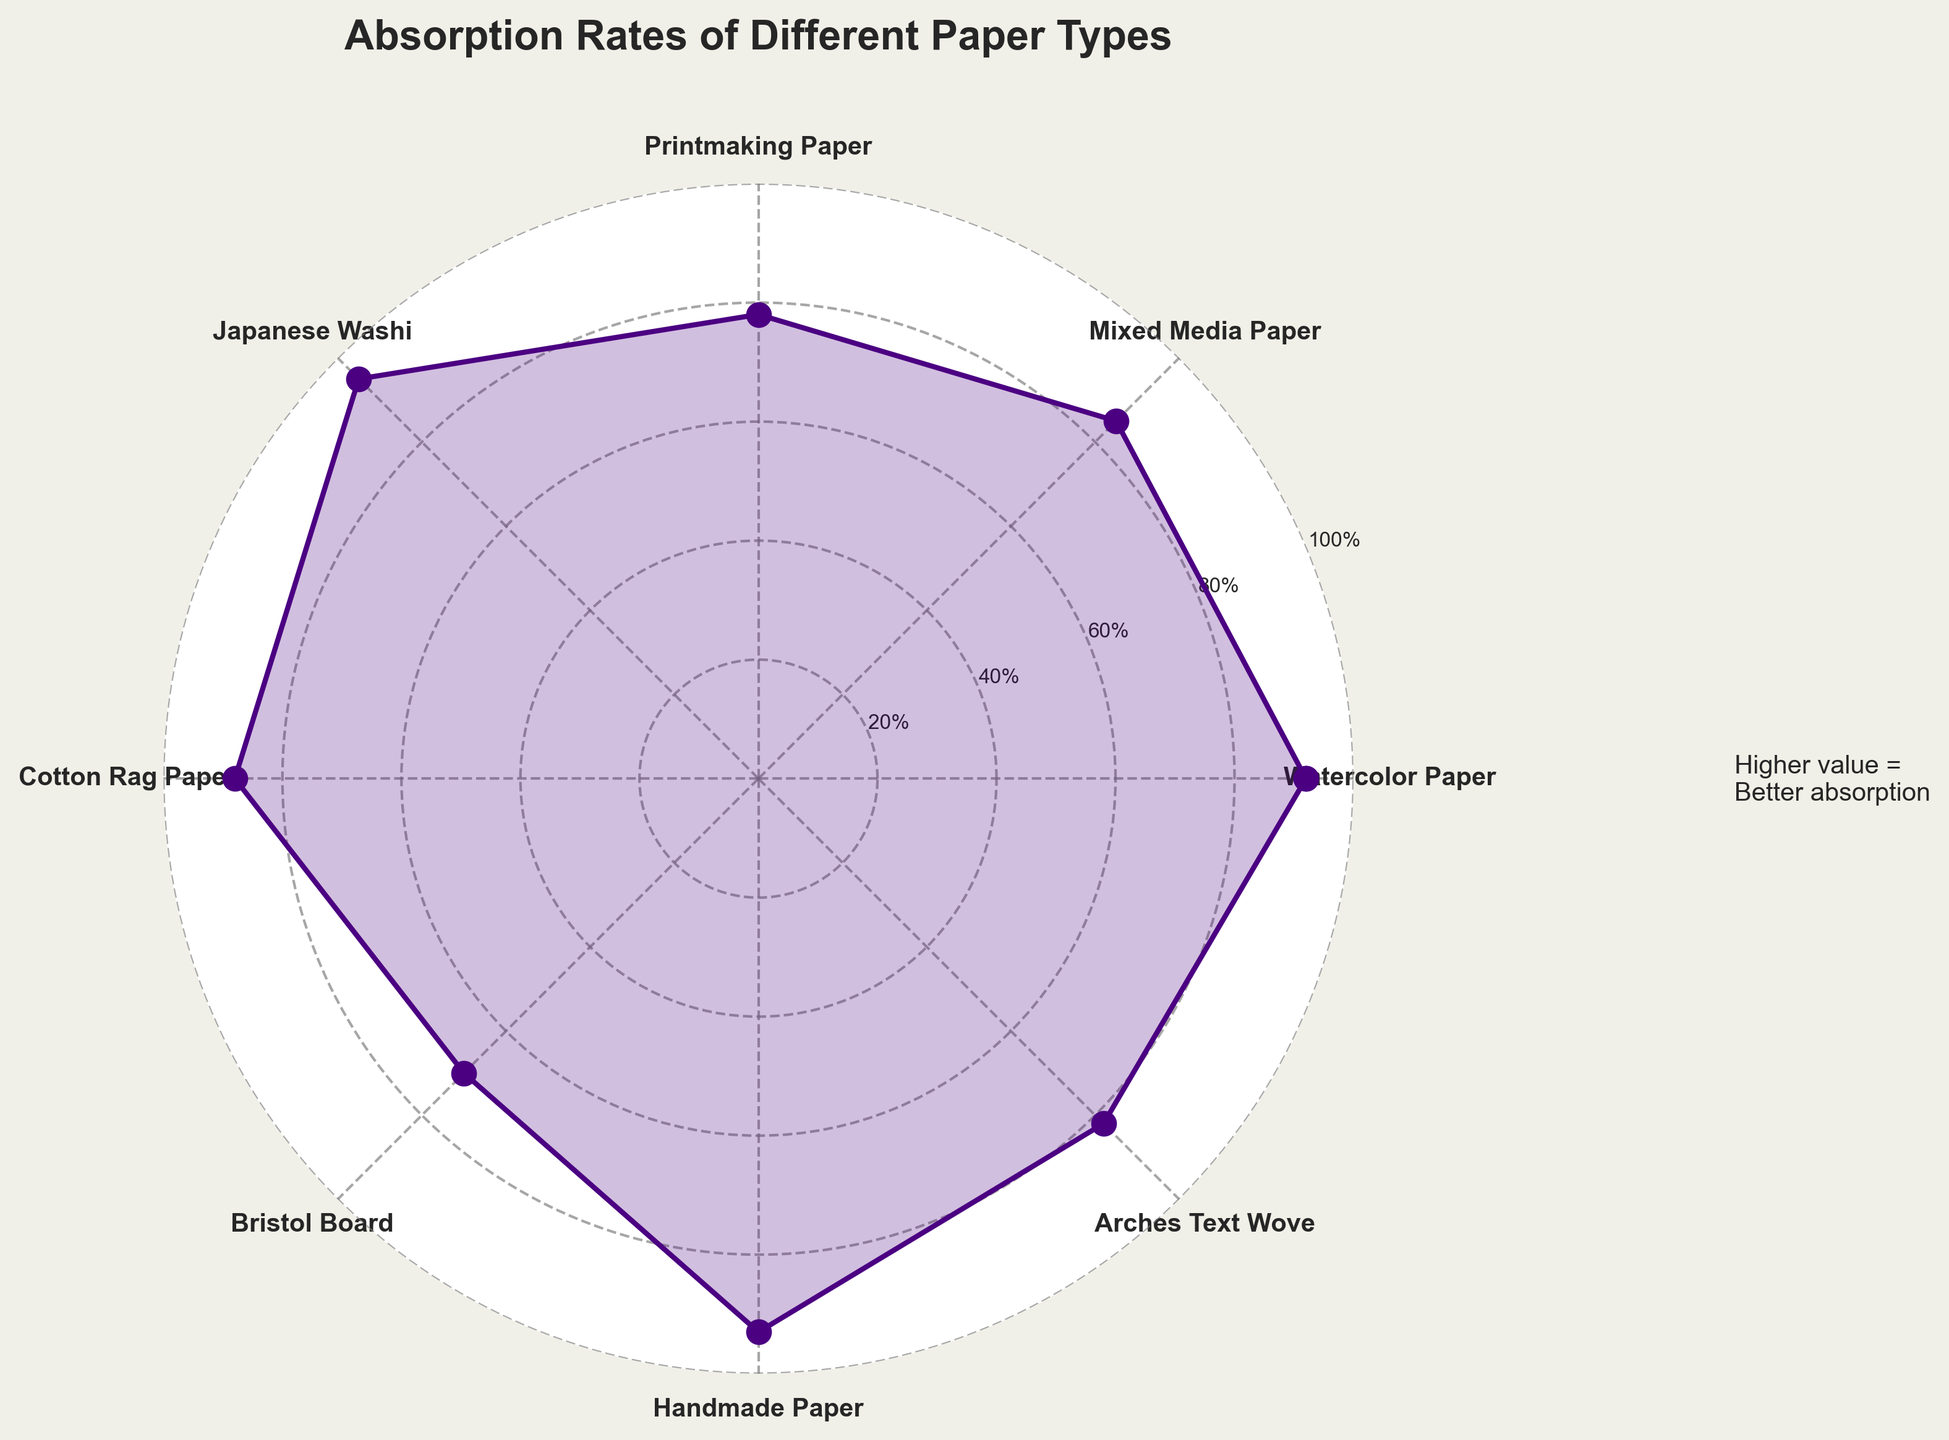What is the title of the gauge chart? The title is located at the top of the chart and is displayed in bold.
Answer: Absorption Rates of Different Paper Types What color is used for plotting the data points and the filled polygon? The color is visually consistent across the data points and the filled area of the polygon.
Answer: Indigo How many different paper types are represented in the gauge chart? Count the number of unique labels distributed around the polar axis of the chart.
Answer: Eight Which paper type has the highest absorption rate? Identify the paper type at the highest value on the radial scale.
Answer: Japanese Washi Which paper type has the lowest absorption rate? Identify the paper type at the lowest value on the radial scale.
Answer: Bristol Board What is the difference in absorption rates between Watercolor Paper and Bristol Board? Subtract the absorption rate of Bristol Board from that of Watercolor Paper.
Answer: 22 Which paper types have absorption rates greater than 90%? Identify paper types with values exceeding 90% on the radial scale.
Answer: Watercolor Paper, Japanese Washi, Handmade Paper What is the average absorption rate of all the paper types? Add all the absorption rates and divide by the number of paper types. The calculation steps are: (92 + 85 + 78 + 95 + 88 + 70 + 93 + 82) / 8 = 83.13
Answer: 83.13 Which paper type is closest to the average absorption rate? Compare each paper type's absorption rate to the average value calculated and find the closest match.
Answer: Mixed Media Paper 